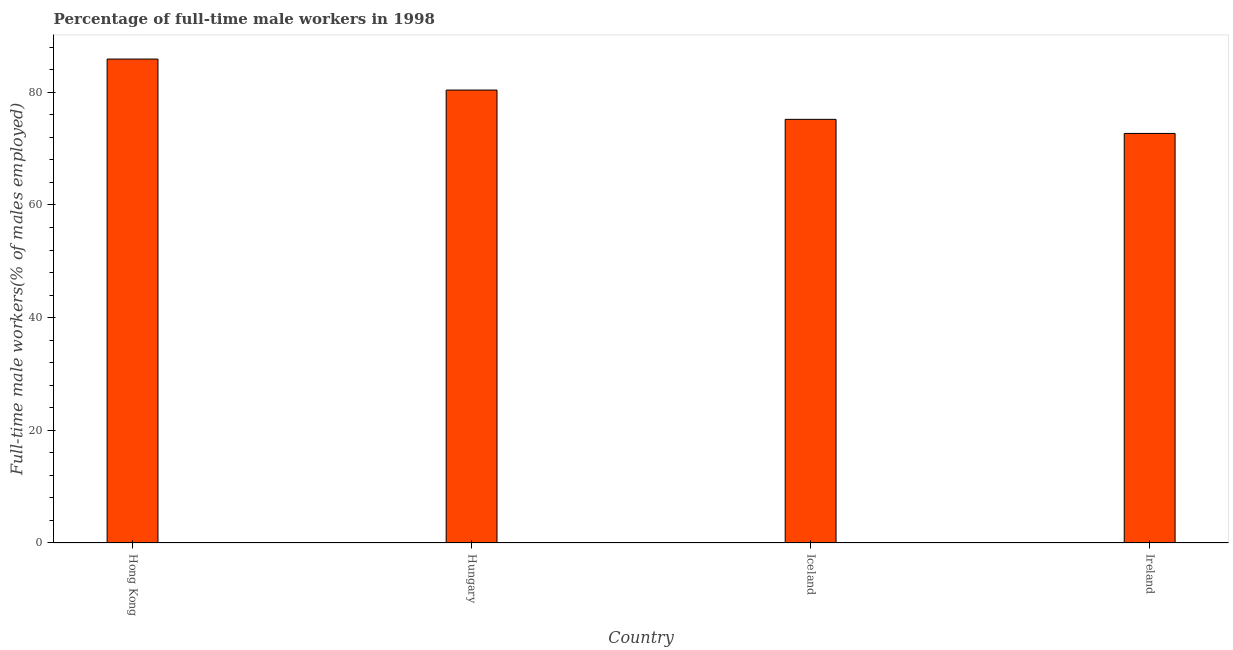Does the graph contain grids?
Your response must be concise. No. What is the title of the graph?
Your response must be concise. Percentage of full-time male workers in 1998. What is the label or title of the Y-axis?
Your answer should be compact. Full-time male workers(% of males employed). What is the percentage of full-time male workers in Ireland?
Your answer should be compact. 72.7. Across all countries, what is the maximum percentage of full-time male workers?
Provide a succinct answer. 85.9. Across all countries, what is the minimum percentage of full-time male workers?
Offer a terse response. 72.7. In which country was the percentage of full-time male workers maximum?
Ensure brevity in your answer.  Hong Kong. In which country was the percentage of full-time male workers minimum?
Make the answer very short. Ireland. What is the sum of the percentage of full-time male workers?
Provide a succinct answer. 314.2. What is the difference between the percentage of full-time male workers in Hungary and Ireland?
Ensure brevity in your answer.  7.7. What is the average percentage of full-time male workers per country?
Provide a succinct answer. 78.55. What is the median percentage of full-time male workers?
Provide a short and direct response. 77.8. In how many countries, is the percentage of full-time male workers greater than 4 %?
Provide a short and direct response. 4. What is the ratio of the percentage of full-time male workers in Iceland to that in Ireland?
Offer a very short reply. 1.03. Is the percentage of full-time male workers in Hungary less than that in Iceland?
Keep it short and to the point. No. Is the difference between the percentage of full-time male workers in Iceland and Ireland greater than the difference between any two countries?
Offer a terse response. No. Is the sum of the percentage of full-time male workers in Hong Kong and Hungary greater than the maximum percentage of full-time male workers across all countries?
Provide a short and direct response. Yes. How many bars are there?
Offer a terse response. 4. Are all the bars in the graph horizontal?
Ensure brevity in your answer.  No. What is the difference between two consecutive major ticks on the Y-axis?
Provide a short and direct response. 20. What is the Full-time male workers(% of males employed) in Hong Kong?
Give a very brief answer. 85.9. What is the Full-time male workers(% of males employed) in Hungary?
Provide a short and direct response. 80.4. What is the Full-time male workers(% of males employed) in Iceland?
Provide a short and direct response. 75.2. What is the Full-time male workers(% of males employed) of Ireland?
Give a very brief answer. 72.7. What is the difference between the Full-time male workers(% of males employed) in Hong Kong and Ireland?
Your answer should be very brief. 13.2. What is the difference between the Full-time male workers(% of males employed) in Iceland and Ireland?
Provide a succinct answer. 2.5. What is the ratio of the Full-time male workers(% of males employed) in Hong Kong to that in Hungary?
Offer a very short reply. 1.07. What is the ratio of the Full-time male workers(% of males employed) in Hong Kong to that in Iceland?
Provide a short and direct response. 1.14. What is the ratio of the Full-time male workers(% of males employed) in Hong Kong to that in Ireland?
Your response must be concise. 1.18. What is the ratio of the Full-time male workers(% of males employed) in Hungary to that in Iceland?
Keep it short and to the point. 1.07. What is the ratio of the Full-time male workers(% of males employed) in Hungary to that in Ireland?
Ensure brevity in your answer.  1.11. What is the ratio of the Full-time male workers(% of males employed) in Iceland to that in Ireland?
Make the answer very short. 1.03. 